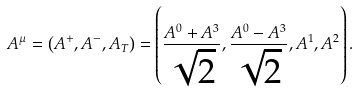<formula> <loc_0><loc_0><loc_500><loc_500>A ^ { \mu } = \left ( A ^ { + } , A ^ { - } , { A _ { T } } \right ) = \left ( \frac { A ^ { 0 } + A ^ { 3 } } { \sqrt { 2 } } , \frac { A ^ { 0 } - A ^ { 3 } } { \sqrt { 2 } } , A ^ { 1 } , A ^ { 2 } \right ) .</formula> 